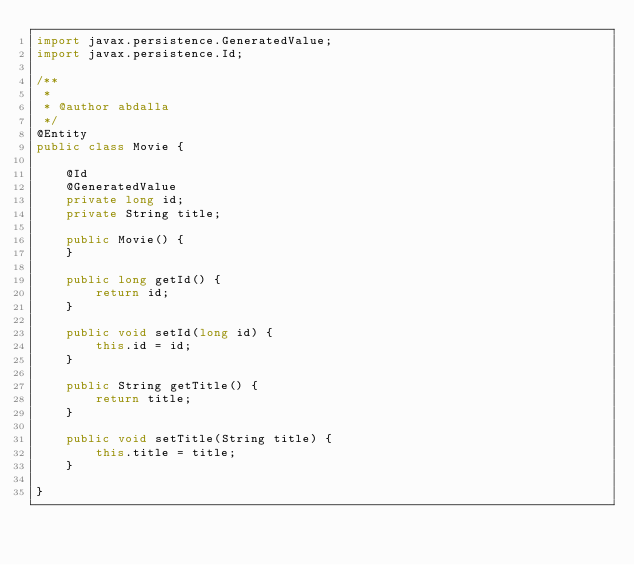Convert code to text. <code><loc_0><loc_0><loc_500><loc_500><_Java_>import javax.persistence.GeneratedValue;
import javax.persistence.Id;

/**
 *
 * @author abdalla
 */
@Entity
public class Movie {

    @Id
    @GeneratedValue
    private long id;
    private String title;

    public Movie() {
    }

    public long getId() {
        return id;
    }

    public void setId(long id) {
        this.id = id;
    }

    public String getTitle() {
        return title;
    }

    public void setTitle(String title) {
        this.title = title;
    }

}
</code> 